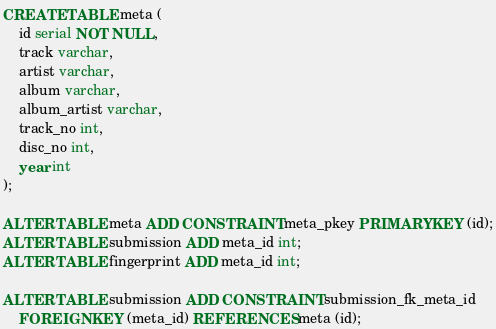Convert code to text. <code><loc_0><loc_0><loc_500><loc_500><_SQL_>CREATE TABLE meta (
    id serial NOT NULL,
    track varchar,
    artist varchar,
    album varchar,
    album_artist varchar,
    track_no int,
    disc_no int,
    year int
);

ALTER TABLE meta ADD CONSTRAINT meta_pkey PRIMARY KEY (id);
ALTER TABLE submission ADD meta_id int;
ALTER TABLE fingerprint ADD meta_id int;

ALTER TABLE submission ADD CONSTRAINT submission_fk_meta_id
    FOREIGN KEY (meta_id) REFERENCES meta (id);</code> 